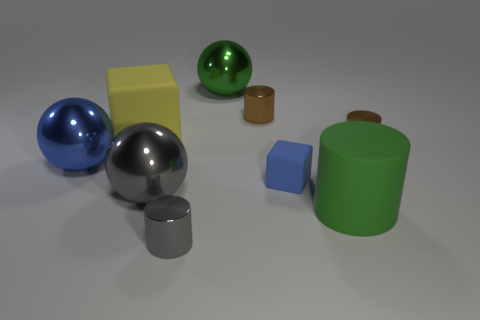There is a small shiny thing right of the green matte cylinder; is it the same color as the small metal thing that is behind the yellow cube?
Provide a short and direct response. Yes. Is the number of large blue spheres less than the number of small brown objects?
Offer a terse response. Yes. There is a brown object behind the brown cylinder to the right of the tiny rubber object; what shape is it?
Make the answer very short. Cylinder. The tiny metallic object to the left of the big green object behind the gray metallic thing that is behind the gray metal cylinder is what shape?
Ensure brevity in your answer.  Cylinder. What number of objects are big things behind the big blue thing or shiny cylinders that are in front of the large blue object?
Provide a succinct answer. 3. There is a green rubber cylinder; does it have the same size as the metallic thing that is to the right of the green rubber object?
Give a very brief answer. No. Is the brown thing that is on the right side of the green matte thing made of the same material as the green thing that is behind the tiny blue rubber cube?
Provide a short and direct response. Yes. Is the number of small cylinders that are right of the tiny gray shiny cylinder the same as the number of small metal objects on the left side of the blue block?
Make the answer very short. Yes. What number of metal balls are the same color as the large rubber cylinder?
Provide a short and direct response. 1. There is a large ball that is the same color as the small matte object; what is it made of?
Make the answer very short. Metal. 